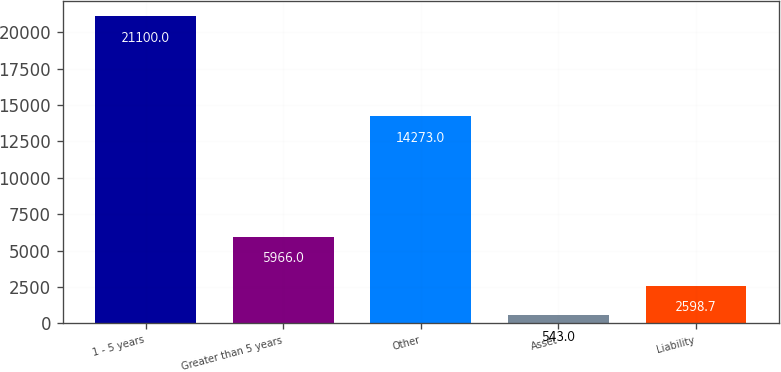<chart> <loc_0><loc_0><loc_500><loc_500><bar_chart><fcel>1 - 5 years<fcel>Greater than 5 years<fcel>Other<fcel>Asset<fcel>Liability<nl><fcel>21100<fcel>5966<fcel>14273<fcel>543<fcel>2598.7<nl></chart> 